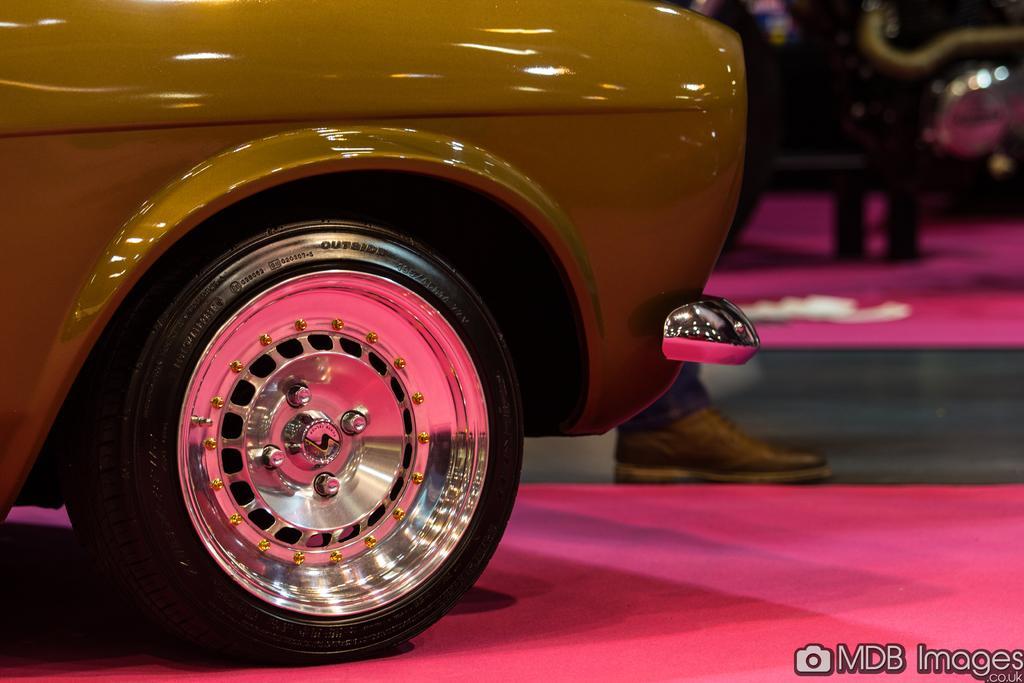Could you give a brief overview of what you see in this image? In this image I can see the vehicle. To the side of the vehicle I can see the human leg wearing the black color shoe. And there is a blurred background. 